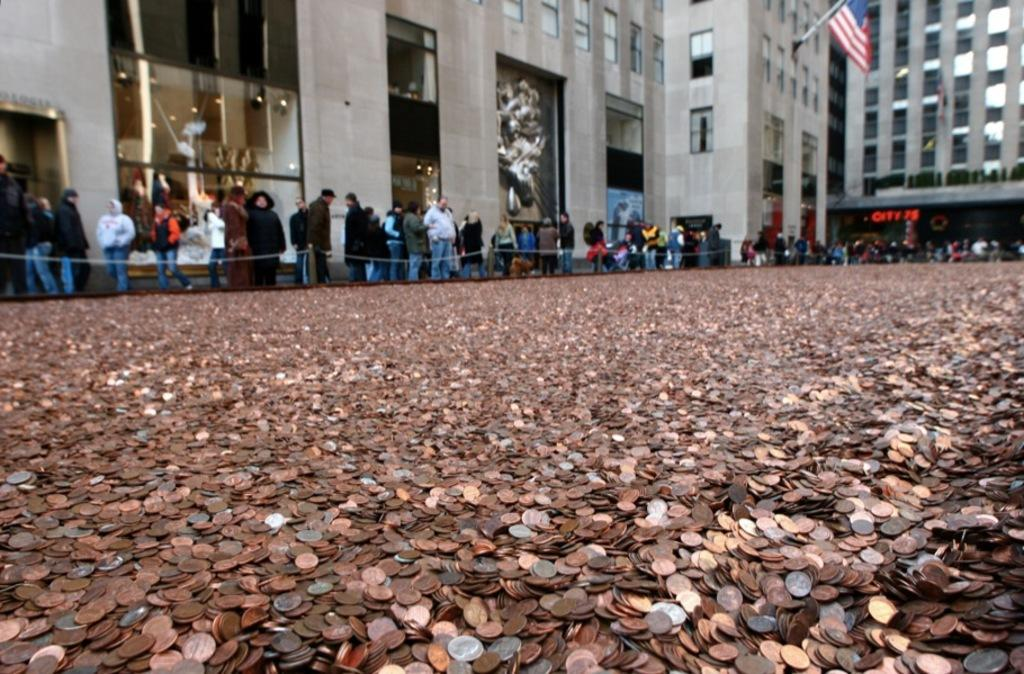What objects can be seen in the image? There are coins in the image. What are the people in the image doing? There are people standing and walking in the image. What can be seen in the background of the image? There are buildings, a flag, and glasses in the background of the image. What type of wound can be seen on the person in the image? There is no wound visible on any person in the image. What type of suit is the person wearing in the image? There is no person wearing a suit in the image. --- Facts: 1. There is a car in the image. 2. The car is red. 3. There are people sitting inside the car. 4. The car has four doors. 5. The car has a sunroof. Absurd Topics: unicorn, rainbow, parrot Conversation: What is the main subject in the image? There is a car in the image. What color is the car? The car is red. What can be seen inside the car? There are people sitting inside the car. How many doors does the car have? The car has four doors. What additional feature does the car have? The car has a sunroof. Reasoning: Let's think step by step in order to ${produce the conversation}. We start by identifying the main subject of the image, which is the car. Next, we describe specific features of the car, such as the color, the number of doors, and the presence of a sunroof. Then, we observe the actions of the people inside the car, noting that they are sitting. Finally, we describe the additional feature of the car, which is the sunroof. Absurd Question/Answer: Can you see a unicorn in the image? No, there is no unicorn present in the image. --- Facts: 1. There is a cat in the image. 2. The cat is black and white. 3. The cat is sitting on a chair. 4. There is a bowl of milk on the table next to the chair. 5. The room has a wooden floor. Absurd Topics: elephant, giraffe, gorilla Conversation: What type of animal can be seen in the image? There is a cat in the image. What is the color pattern of the cat? The cat is black and white. What is the cat doing in the image? The cat is sitting on a chair. What can be seen on the table next to the chair? There is a bowl of milk on the table next to the chair. What type of flooring is present in the room? The room has a wooden floor. Reasoning: Let's think step by step in order to ${produ 